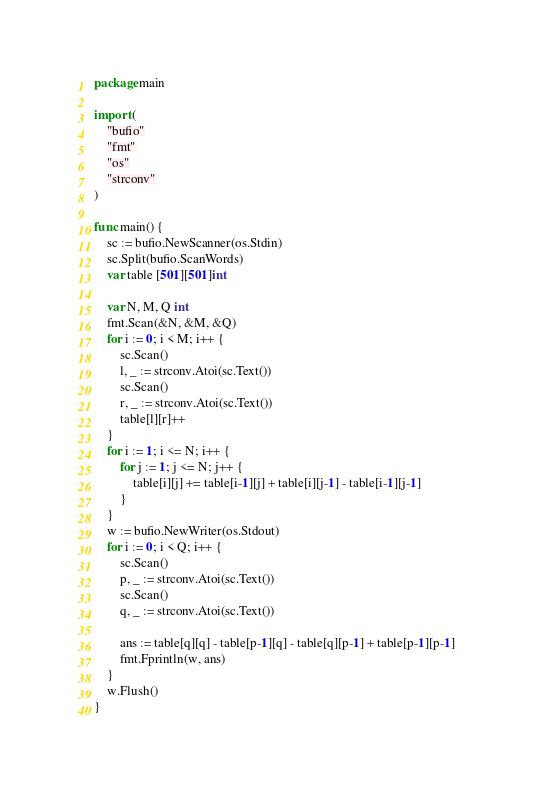<code> <loc_0><loc_0><loc_500><loc_500><_Go_>package main

import (
	"bufio"
	"fmt"
	"os"
	"strconv"
)

func main() {
	sc := bufio.NewScanner(os.Stdin)
	sc.Split(bufio.ScanWords)
	var table [501][501]int

	var N, M, Q int
	fmt.Scan(&N, &M, &Q)
	for i := 0; i < M; i++ {
		sc.Scan()
		l, _ := strconv.Atoi(sc.Text())
		sc.Scan()
		r, _ := strconv.Atoi(sc.Text())
		table[l][r]++
	}
	for i := 1; i <= N; i++ {
		for j := 1; j <= N; j++ {
			table[i][j] += table[i-1][j] + table[i][j-1] - table[i-1][j-1]
		}
	}
	w := bufio.NewWriter(os.Stdout)
	for i := 0; i < Q; i++ {
		sc.Scan()
		p, _ := strconv.Atoi(sc.Text())
		sc.Scan()
		q, _ := strconv.Atoi(sc.Text())

		ans := table[q][q] - table[p-1][q] - table[q][p-1] + table[p-1][p-1]
		fmt.Fprintln(w, ans)
	}
	w.Flush()
}
</code> 